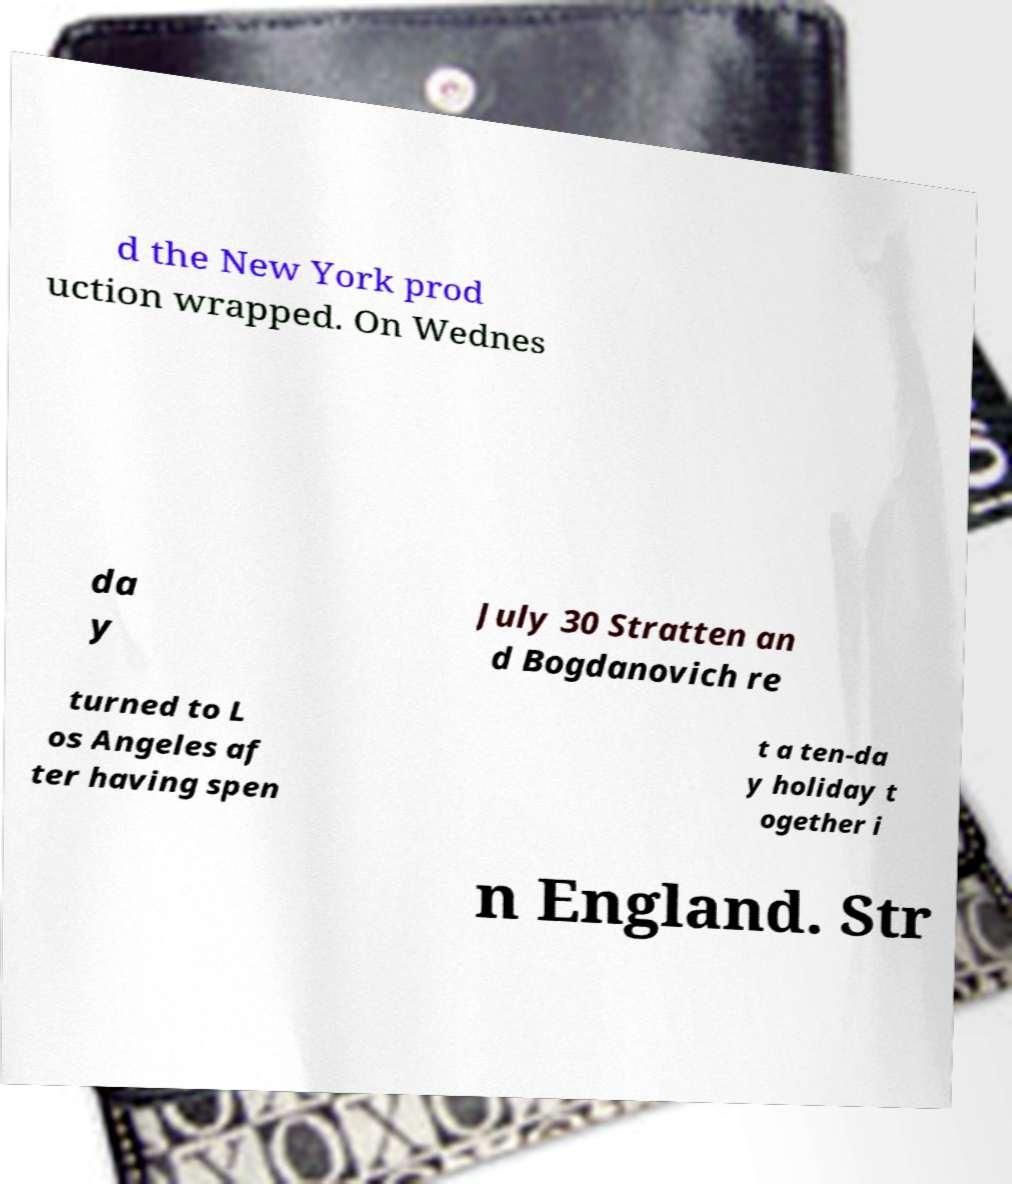Please read and relay the text visible in this image. What does it say? d the New York prod uction wrapped. On Wednes da y July 30 Stratten an d Bogdanovich re turned to L os Angeles af ter having spen t a ten-da y holiday t ogether i n England. Str 